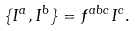<formula> <loc_0><loc_0><loc_500><loc_500>\{ I ^ { a } , I ^ { b } \} = f ^ { a b c } I ^ { c } .</formula> 